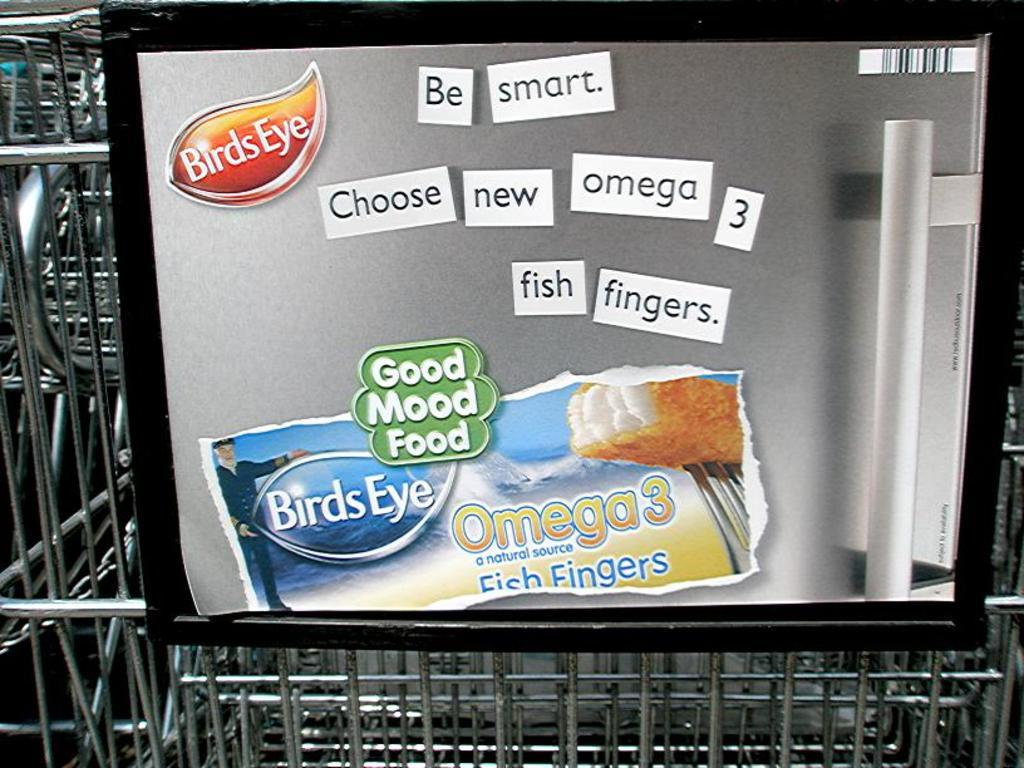<image>
Present a compact description of the photo's key features. A small advertisement for Birds Eye fish fingers on a shopping cart. 